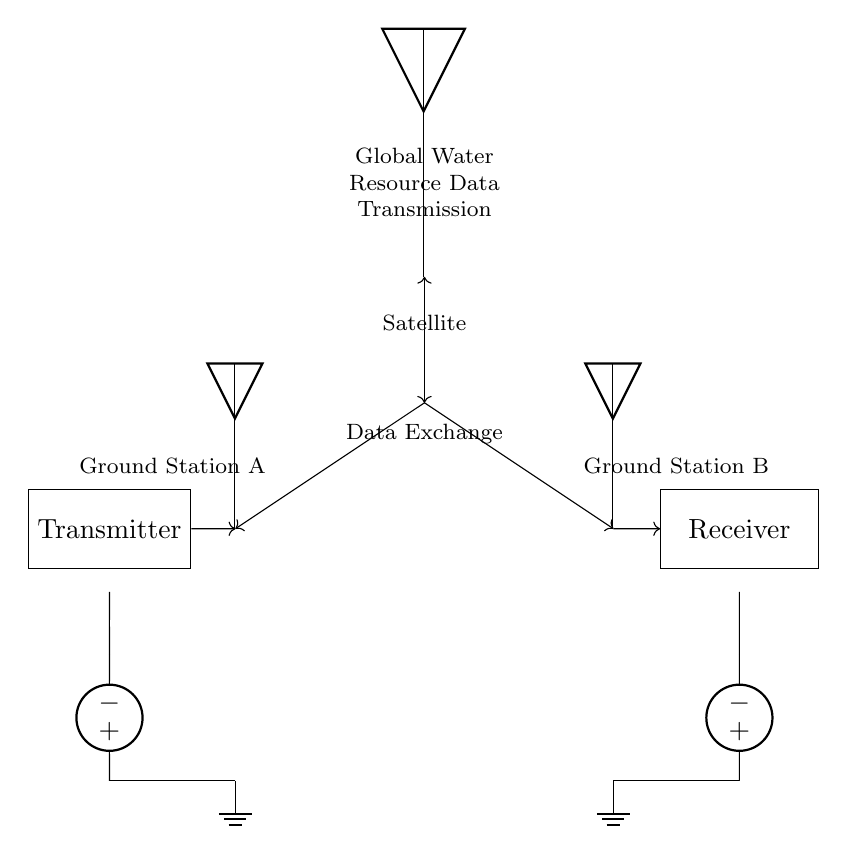What type of devices are used for data transmission in this circuit? The circuit uses a transmitter and a receiver for data transmission. The transmitter sends data, while the receiver receives it.
Answer: Transmitter and Receiver How many ground stations are displayed in the circuit? The circuit diagram shows two ground stations, labeled as Ground Station A and Ground Station B.
Answer: Two What role does the satellite play in this circuit? The satellite acts as a communication link between the two ground stations, facilitating data exchange by connecting them wirelessly.
Answer: Communication link What is the input component of the transmitter? The input component of the transmitter is an American voltage source, supplying power to the transmitter before transmitting the data.
Answer: American voltage source How does data travel from Ground Station A to Ground Station B? Data travels from Ground Station A, through the transmitter to an antenna, then to the satellite, and finally to the antenna for Ground Station B before being received.
Answer: Through antennas and satellite Which component is responsible for data exchange indicated in the circuit? The antennas at Ground Station A and Ground Station B are responsible for the data exchange. They connect the ground stations to the satellite for communication.
Answer: Antennas 